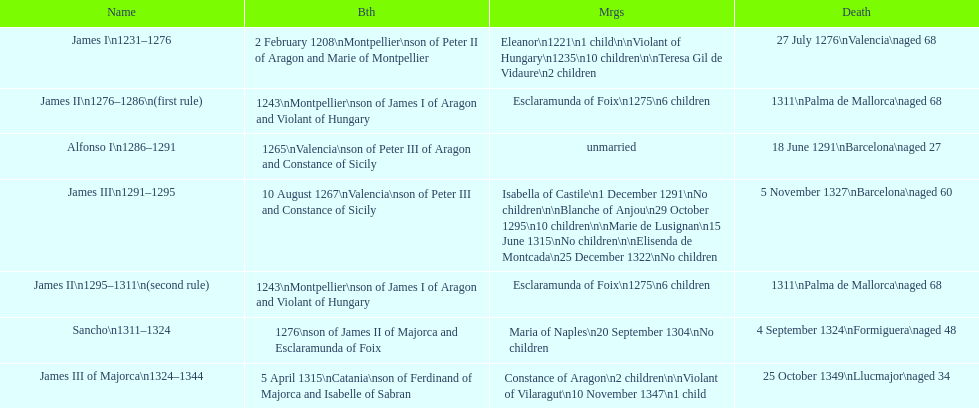Which two monarchs had no children? Alfonso I, Sancho. 